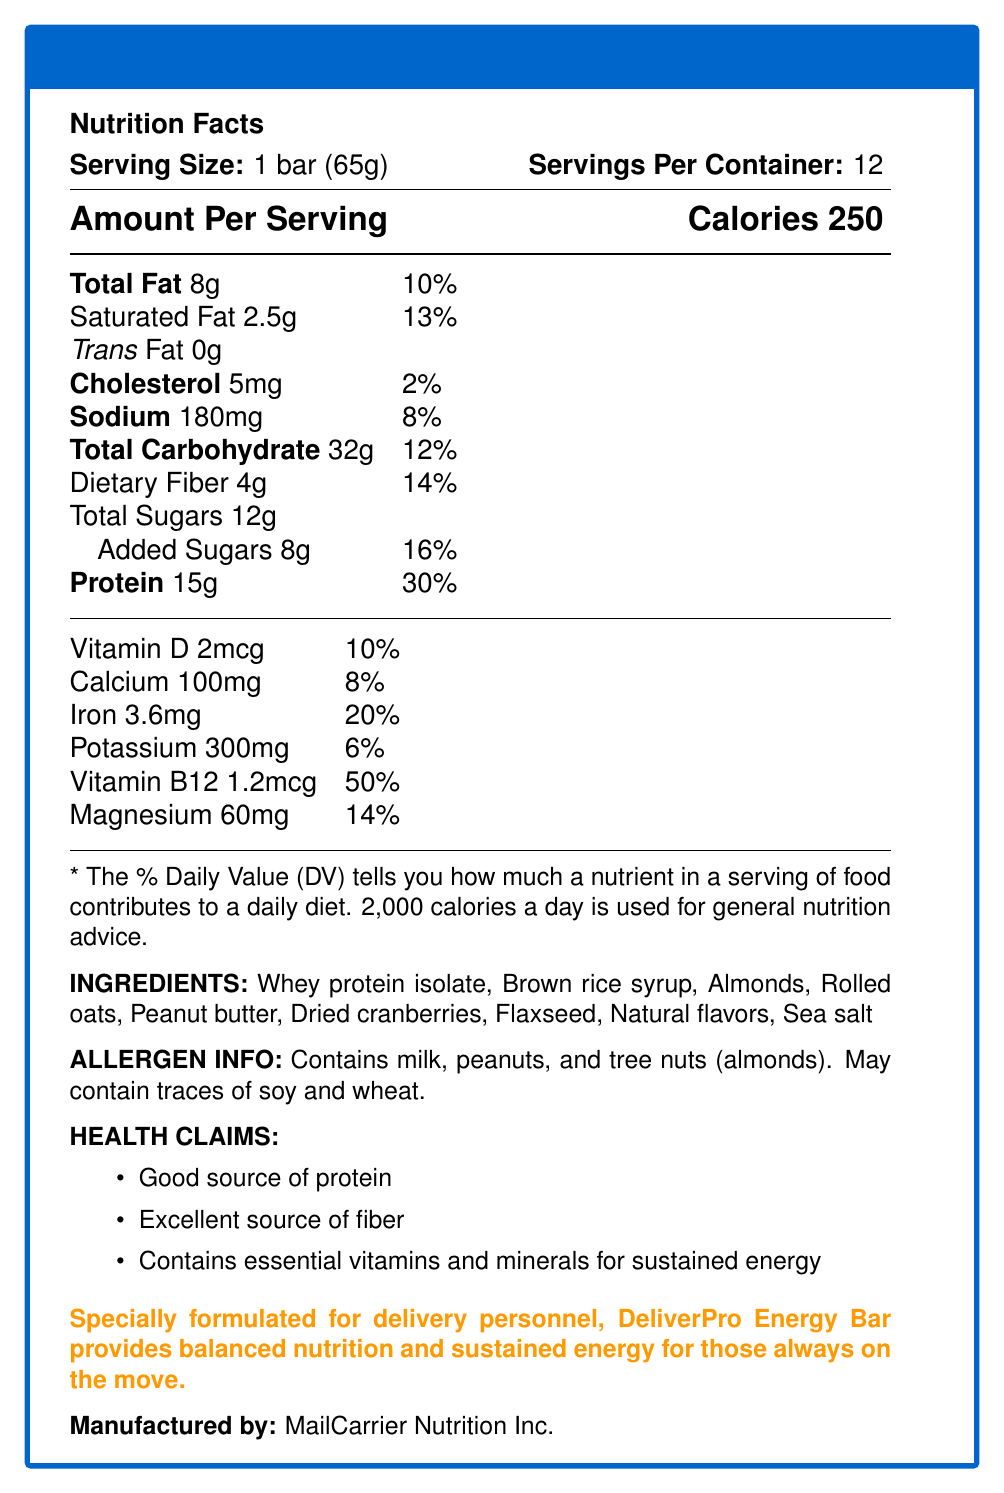What is the serving size of the DeliverPro Energy Bar? The serving size is mentioned under the title "Serving Size" as "1 bar (65g)".
Answer: 1 bar (65g) How many servings are there per container? The number of servings per container is listed next to the serving size as "Servings Per Container: 12".
Answer: 12 How many grams of protein does each DeliverPro Energy Bar contain? Under the nutrition facts, it states "Protein 15g".
Answer: 15g What percentage of the daily value of dietary fiber is provided by each serving? The daily value percentage for dietary fiber is listed as "Dietary Fiber 4g & 14%".
Answer: 14% Which vitamins and minerals are specially highlighted for their contributions in the DeliverPro Energy Bar? These nutrients are listed under their respective amounts with daily values in the nutrition facts section.
Answer: Vitamin D, Calcium, Iron, Potassium, Vitamin B12, and Magnesium What is the total amount of sugars in one DeliverPro Energy Bar? A. 8g B. 12g C. 20g D. 16g The total amount of sugars is listed as "Total Sugars 12g".
Answer: B. 12g Which of the following ingredients are in the DeliverPro Energy Bar? I. Whey protein isolate II. Soy protein isolate III. Almonds IV. Rolled oats V. Raisins The ingredients list includes Whey protein isolate, Almonds, and Rolled oats but not Soy protein isolate or Raisins.
Answer: I, III, and IV Does the DeliverPro Energy Bar contain any trans fat? The nutrition facts list trans fat as "0g", meaning the bar contains no trans fat.
Answer: No Summarize the purpose and key nutritional attributes of the DeliverPro Energy Bar. The summary of the document highlights the bar's design for delivery workers, its balanced nutrition, high protein and fiber content, and inclusion of essential vitamins and minerals.
Answer: Specially formulated for delivery personnel, DeliverPro Energy Bar provides balanced nutrition and sustained energy for those always on the move. Packed with protein, fiber, and essential nutrients, it includes 15g of protein, 4g of dietary fiber, vitamins, and minerals. It's suited to support the demanding schedules of mail carriers and delivery drivers. What is the total caloric intake if a mail carrier consumes two DeliverPro Energy Bars? Each bar contains 250 calories. Therefore, consuming two bars would result in a dietary intake of 250 calories x 2 = 500 calories.
Answer: 500 calories Which company manufactures the DeliverPro Energy Bar? The manufacturer is listed at the bottom of the document as "MailCarrier Nutrition Inc.".
Answer: MailCarrier Nutrition Inc. How much magnesium is present in each serving of the DeliverPro Energy Bar? The amount of magnesium is listed in the nutrition facts as "Magnesium 60mg".
Answer: 60mg Can this document provide information about recommended daily calorie intake? The document states that "2,000 calories a day is used for general nutrition advice."
Answer: Yes Does the DeliverPro Energy Bar cater to individuals with nut allergies? The allergen information clearly states that the bar contains milk, peanuts, and tree nuts (almonds), and may contain traces of soy and wheat.
Answer: No How effective is the DeliverPro Energy Bar in providing a significant vitamin B12 contribution? A. Not effective B. Moderately effective C. Very effective D. Cannot be determined Each serving provides 50% of the daily value for vitamin B12, making it a very significant contribution.
Answer: C. Very effective What is the amount of added sugars in the DeliverPro Energy Bar? The amount of added sugars is listed as "Added Sugars 8g".
Answer: 8g What is one of the health claims made about the DeliverPro Energy Bar? The health claims section lists "Good source of protein" among its health claims.
Answer: Good source of protein Which essential vitamin or mineral has the highest percentage Daily Value in the DeliverPro Energy Bar? Vitamin B12 has a Daily Value of 50%, which is higher than the other nutrients listed.
Answer: Vitamin B12 What is MailCarrier Nutrition Inc.'s main reason for formulating the DeliverPro Energy Bar? This purpose is explicitly stated in the product description at the end of the document.
Answer: To provide balanced nutrition and sustained energy for delivery personnel How long does it take to consume an entire container of DeliverPro Energy Bars if a mail carrier eats one bar per day? Since there are 12 bars per container and one bar is consumed each day, it will take 12 days to consume the entire container.
Answer: 12 days What kind of flavors are used in the making of the DeliverPro Energy Bar? The ingredients list includes "Natural flavors".
Answer: Natural flavors Which allergen information cannot be determined from the document? The allergen info states it *may* contain traces of soy and wheat but does not specify the amount or certainty of their presence, so it cannot be determined.
Answer: The specific amount of soy or wheat traces if present 